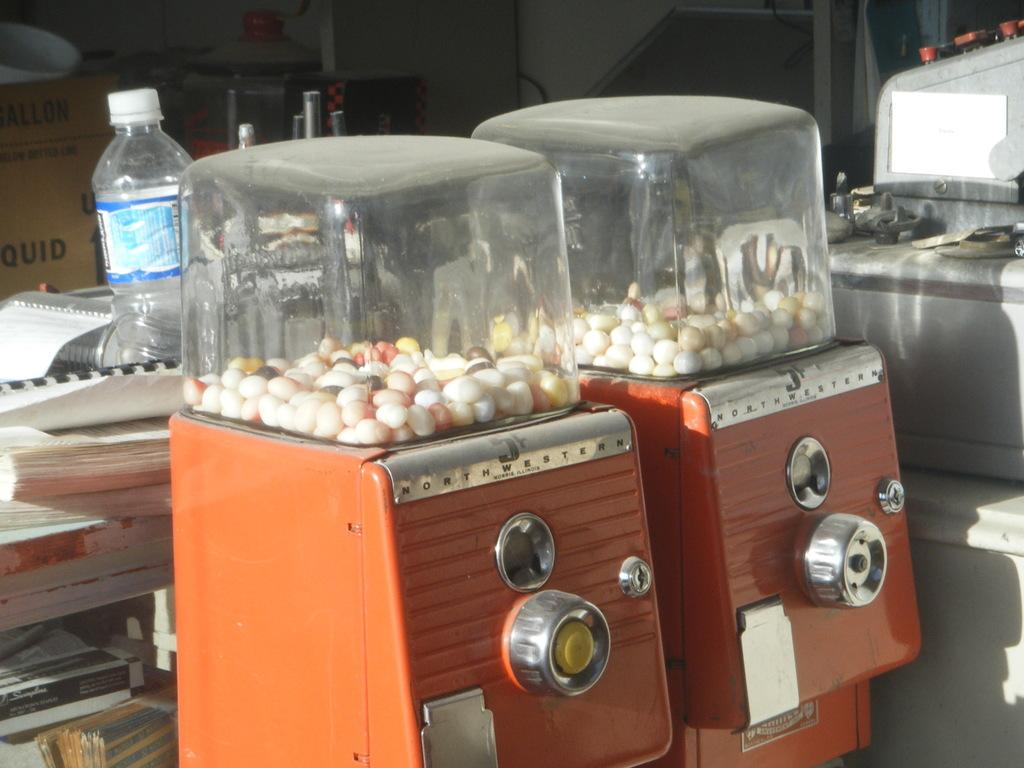What can be found in the image? There are two machines in the image, and they contain candies. What else is visible in the background of the image? There are books in the background of the image, and a water bottle is placed on the books. What type of disease can be seen affecting the machines in the image? There is no disease present in the image; it features two machines containing candies and books with a water bottle. 